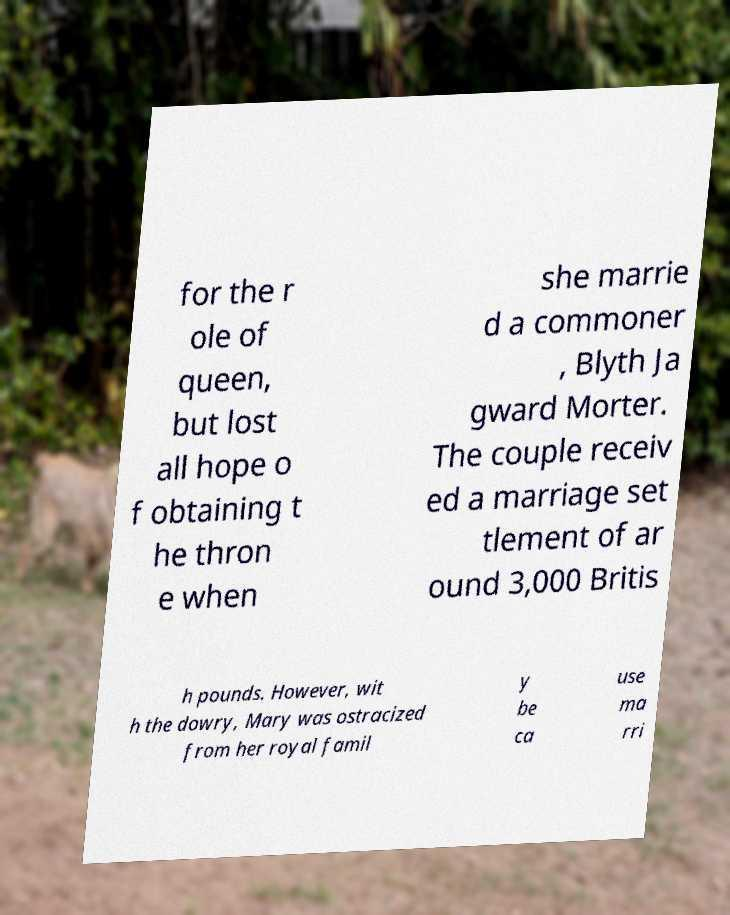Can you accurately transcribe the text from the provided image for me? for the r ole of queen, but lost all hope o f obtaining t he thron e when she marrie d a commoner , Blyth Ja gward Morter. The couple receiv ed a marriage set tlement of ar ound 3,000 Britis h pounds. However, wit h the dowry, Mary was ostracized from her royal famil y be ca use ma rri 